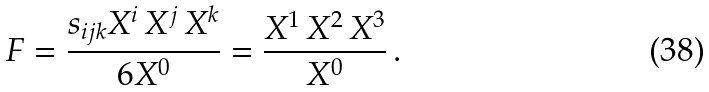<formula> <loc_0><loc_0><loc_500><loc_500>F = \frac { s _ { i j k } X ^ { i } \, X ^ { j } \, X ^ { k } } { 6 X ^ { 0 } } = \frac { X ^ { 1 } \, X ^ { 2 } \, X ^ { 3 } } { X ^ { 0 } } \, .</formula> 